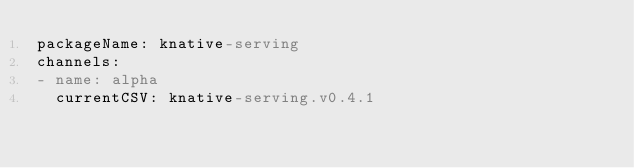<code> <loc_0><loc_0><loc_500><loc_500><_YAML_>packageName: knative-serving
channels:
- name: alpha
  currentCSV: knative-serving.v0.4.1
</code> 